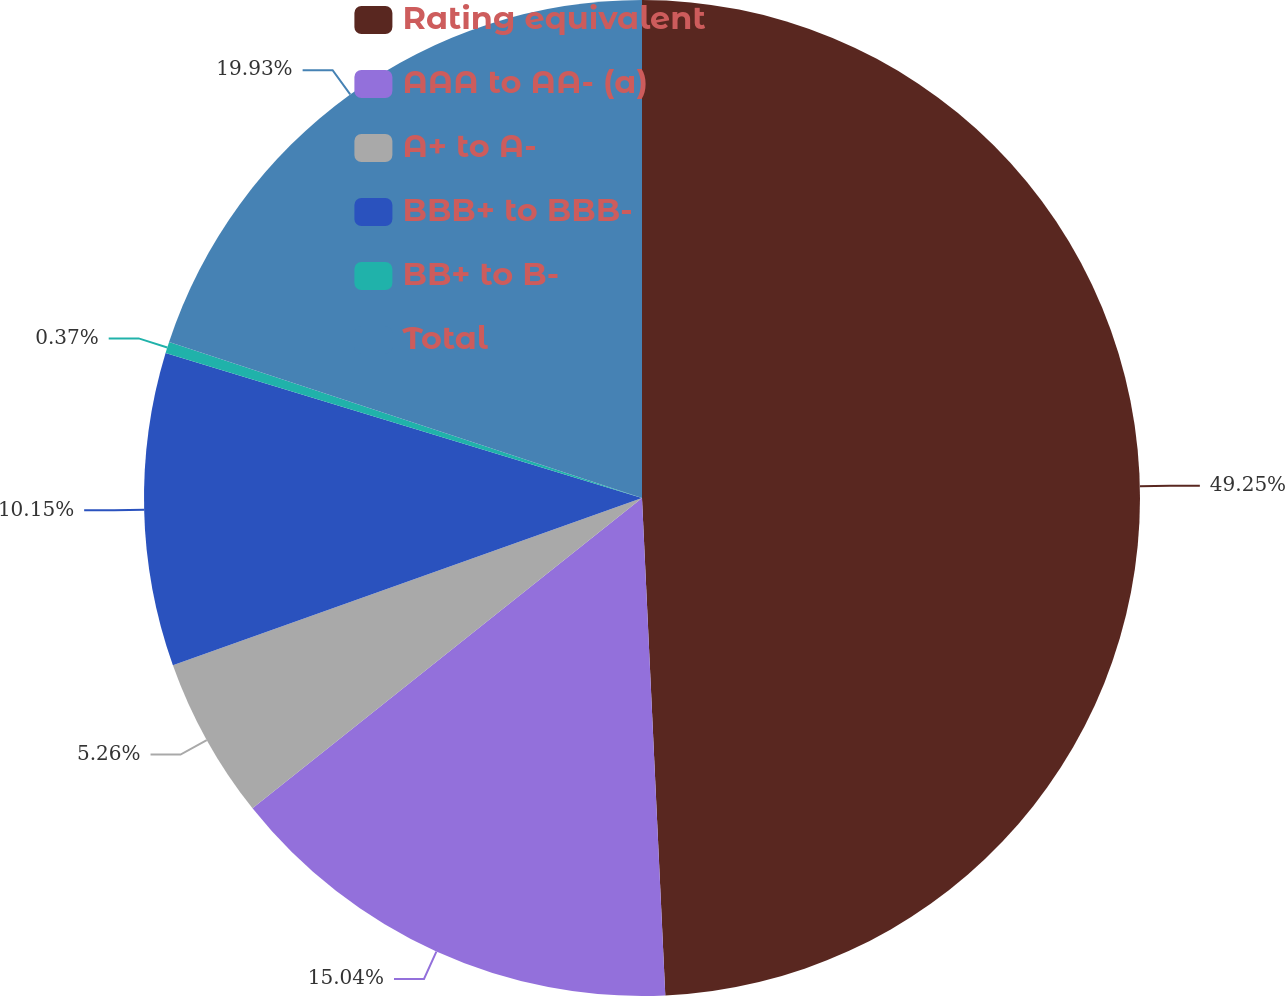<chart> <loc_0><loc_0><loc_500><loc_500><pie_chart><fcel>Rating equivalent<fcel>AAA to AA- (a)<fcel>A+ to A-<fcel>BBB+ to BBB-<fcel>BB+ to B-<fcel>Total<nl><fcel>49.26%<fcel>15.04%<fcel>5.26%<fcel>10.15%<fcel>0.37%<fcel>19.93%<nl></chart> 